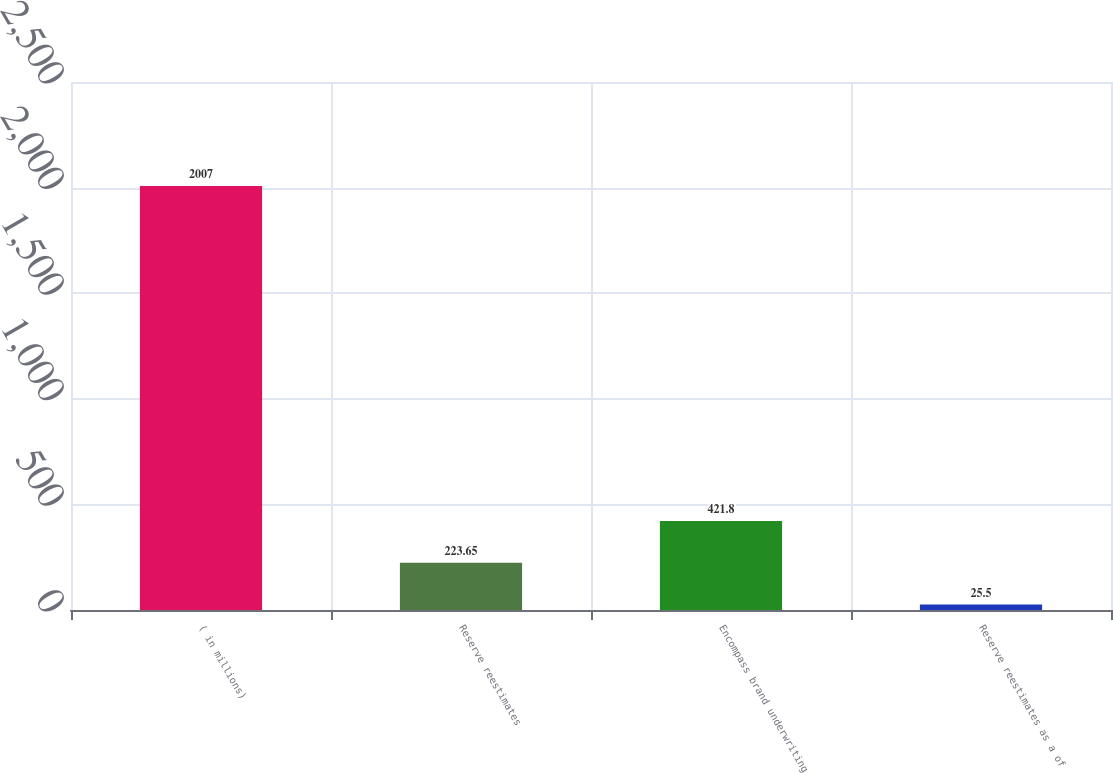Convert chart. <chart><loc_0><loc_0><loc_500><loc_500><bar_chart><fcel>( in millions)<fcel>Reserve reestimates<fcel>Encompass brand underwriting<fcel>Reserve reestimates as a of<nl><fcel>2007<fcel>223.65<fcel>421.8<fcel>25.5<nl></chart> 